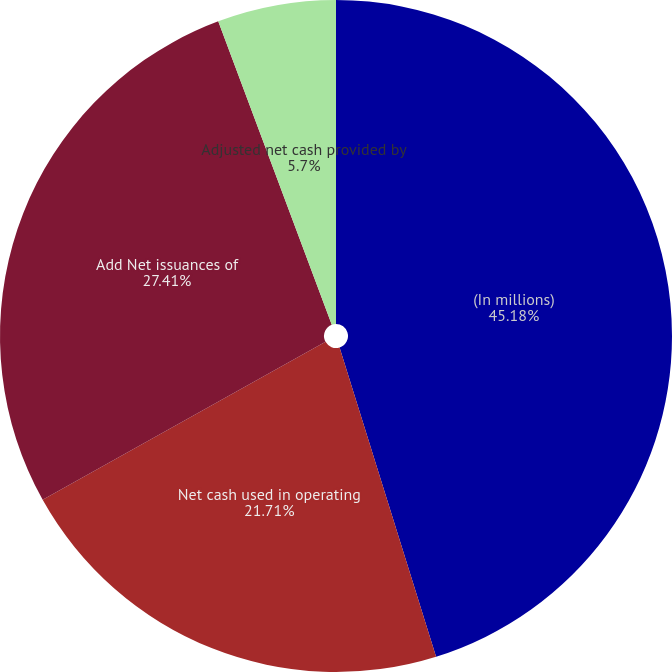<chart> <loc_0><loc_0><loc_500><loc_500><pie_chart><fcel>(In millions)<fcel>Net cash used in operating<fcel>Add Net issuances of<fcel>Adjusted net cash provided by<nl><fcel>45.19%<fcel>21.71%<fcel>27.41%<fcel>5.7%<nl></chart> 